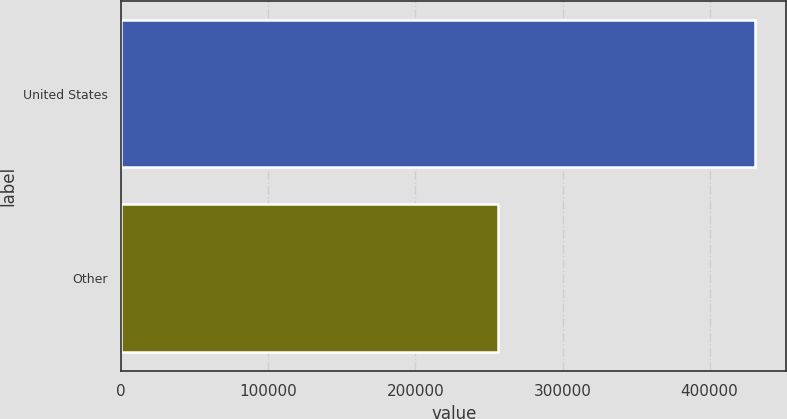<chart> <loc_0><loc_0><loc_500><loc_500><bar_chart><fcel>United States<fcel>Other<nl><fcel>430573<fcel>256108<nl></chart> 